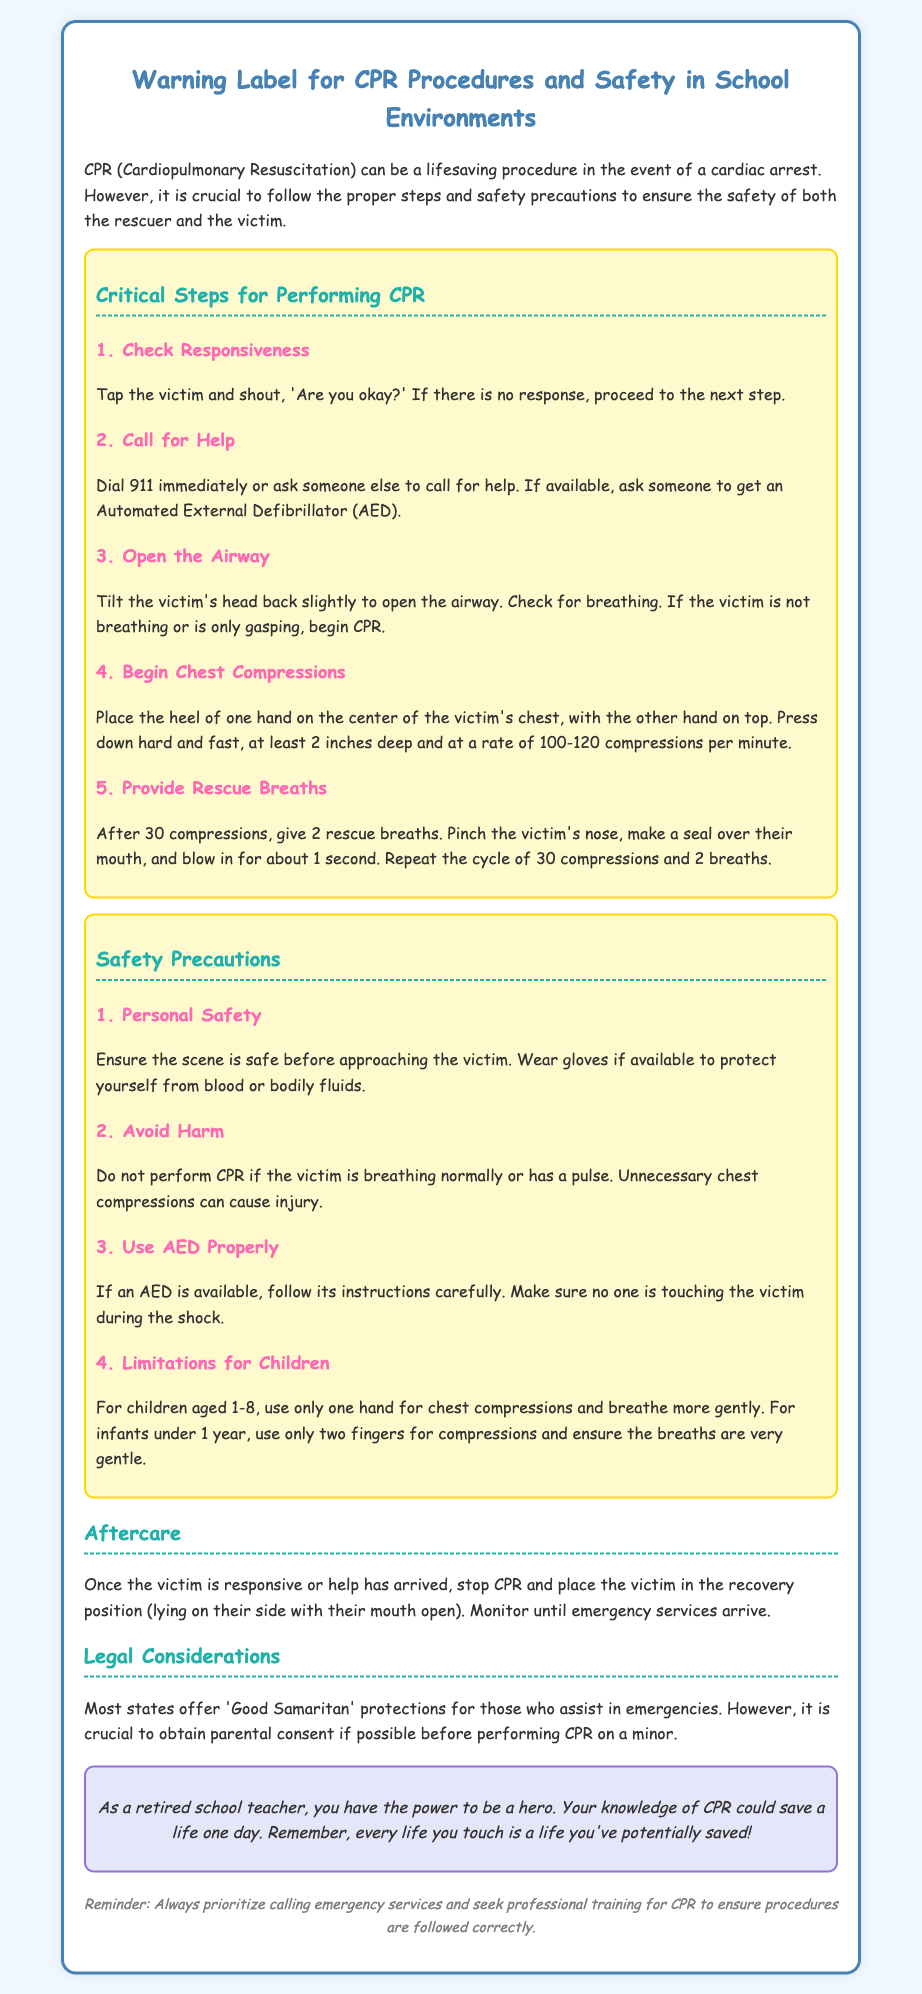What is the title of the document? The title is stated at the top of the document, summarizing the content regarding CPR procedures and safety in school environments.
Answer: Warning Label for CPR Procedures and Safety in School Environments What is the first critical step for performing CPR? The first step listed under the critical steps section specifies checking the victim's responsiveness.
Answer: Check Responsiveness How deep should chest compressions be? The document specifies the depth of compressions required for effective CPR.
Answer: At least 2 inches deep What should be done immediately after calling for help? The document suggests proceeding with a specific action after contacting emergency services.
Answer: Open the Airway How many rescue breaths are given after 30 compressions? This information is included in the procedure for providing rescue breaths during CPR.
Answer: 2 rescue breaths What is a safety precaution related to personal safety? The document highlights the importance of assessing safety before approaching the victim.
Answer: Ensure the scene is safe At what age should only one hand be used for chest compressions? The document specifies the age range where the technique of CPR varies based on the child's age.
Answer: Aged 1-8 What does the hero note say about retired school teachers? The note expresses a sentiment directed towards retired school teachers, emphasizing their potential impact.
Answer: You have the power to be a hero What should you do once the victim is responsive? The document outlines the action to be taken after the victim shows signs of responsiveness.
Answer: Place the victim in the recovery position 